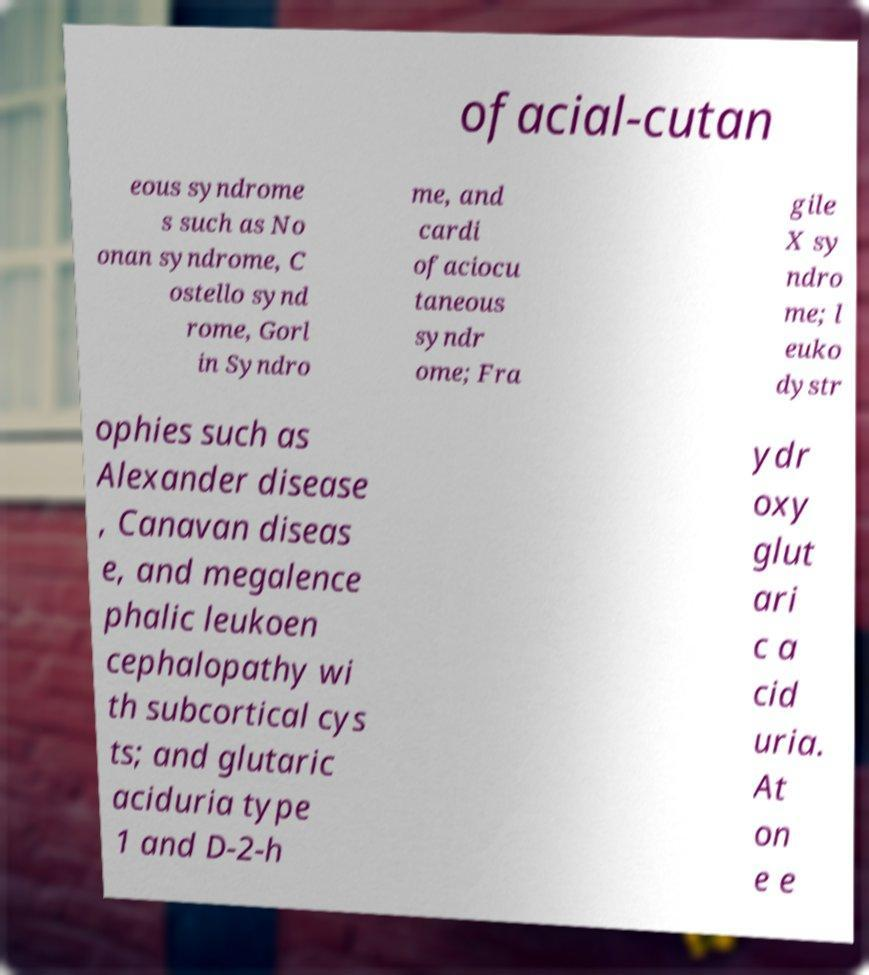Could you extract and type out the text from this image? ofacial-cutan eous syndrome s such as No onan syndrome, C ostello synd rome, Gorl in Syndro me, and cardi ofaciocu taneous syndr ome; Fra gile X sy ndro me; l euko dystr ophies such as Alexander disease , Canavan diseas e, and megalence phalic leukoen cephalopathy wi th subcortical cys ts; and glutaric aciduria type 1 and D-2-h ydr oxy glut ari c a cid uria. At on e e 